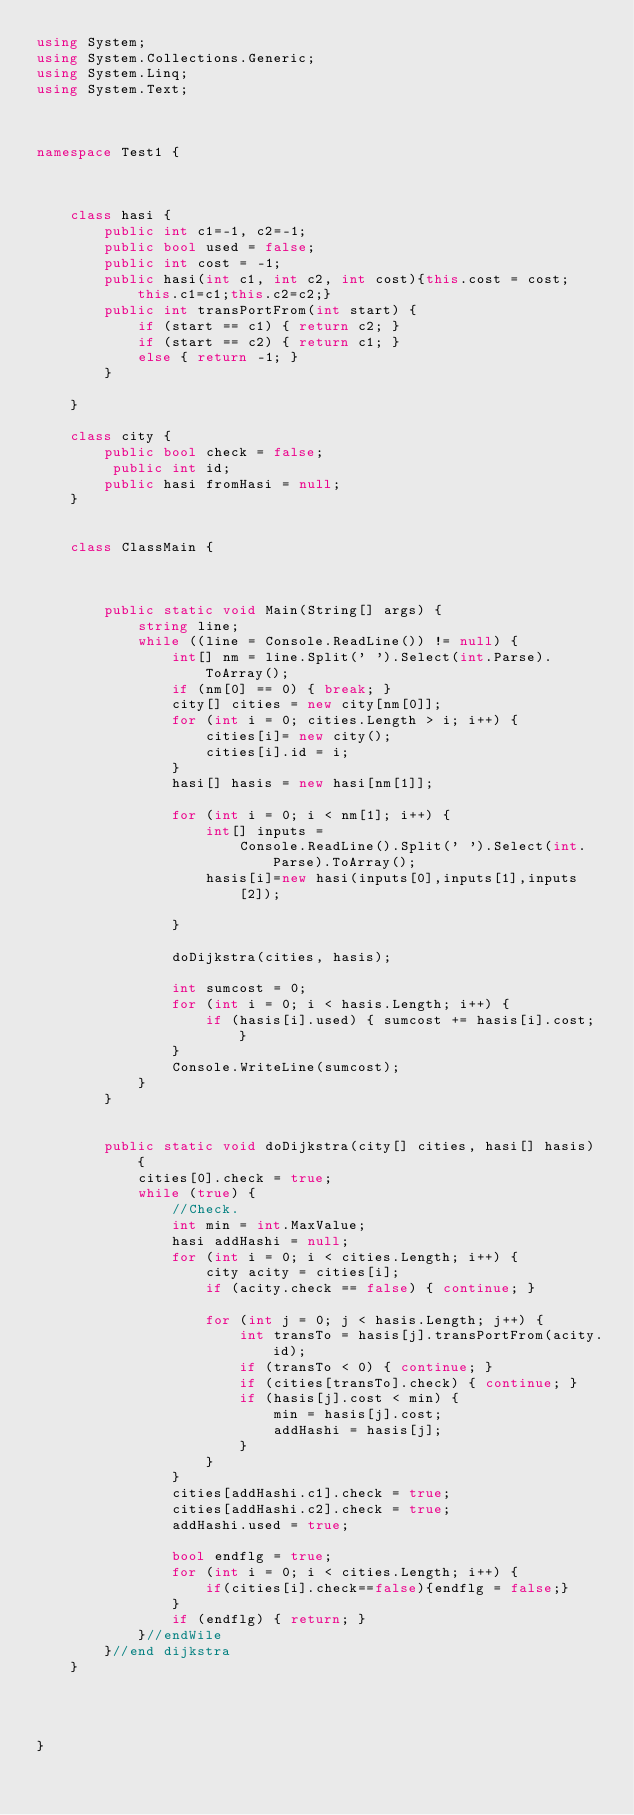<code> <loc_0><loc_0><loc_500><loc_500><_C#_>using System;
using System.Collections.Generic;
using System.Linq;
using System.Text;



namespace Test1 {



    class hasi {
        public int c1=-1, c2=-1;
        public bool used = false;
        public int cost = -1;
        public hasi(int c1, int c2, int cost){this.cost = cost; this.c1=c1;this.c2=c2;}
        public int transPortFrom(int start) {
            if (start == c1) { return c2; }
            if (start == c2) { return c1; }
            else { return -1; }
        }

    }

    class city {
        public bool check = false;
         public int id;
        public hasi fromHasi = null;
    }


    class ClassMain {

       

        public static void Main(String[] args) {
            string line;
            while ((line = Console.ReadLine()) != null) {
                int[] nm = line.Split(' ').Select(int.Parse).ToArray();
                if (nm[0] == 0) { break; }
                city[] cities = new city[nm[0]];
                for (int i = 0; cities.Length > i; i++) { 
                    cities[i]= new city();
                    cities[i].id = i; 
                }
                hasi[] hasis = new hasi[nm[1]];

                for (int i = 0; i < nm[1]; i++) {
                    int[] inputs =
                        Console.ReadLine().Split(' ').Select(int.Parse).ToArray();
                    hasis[i]=new hasi(inputs[0],inputs[1],inputs[2]);

                }

                doDijkstra(cities, hasis);

                int sumcost = 0;
                for (int i = 0; i < hasis.Length; i++) {
                    if (hasis[i].used) { sumcost += hasis[i].cost; }
                }
                Console.WriteLine(sumcost);
            }
        }


        public static void doDijkstra(city[] cities, hasi[] hasis) {
            cities[0].check = true;
            while (true) {
                //Check.
                int min = int.MaxValue;
                hasi addHashi = null;
                for (int i = 0; i < cities.Length; i++) {
                    city acity = cities[i];
                    if (acity.check == false) { continue; }
                    
                    for (int j = 0; j < hasis.Length; j++) {
                        int transTo = hasis[j].transPortFrom(acity.id);
                        if (transTo < 0) { continue; }
                        if (cities[transTo].check) { continue; }
                        if (hasis[j].cost < min) {
                            min = hasis[j].cost;
                            addHashi = hasis[j];
                        }
                    }
                }
                cities[addHashi.c1].check = true;
                cities[addHashi.c2].check = true;
                addHashi.used = true;

                bool endflg = true;
                for (int i = 0; i < cities.Length; i++) {
                    if(cities[i].check==false){endflg = false;}
                }
                if (endflg) { return; }
            }//endWile
        }//end dijkstra
    }



    
}</code> 